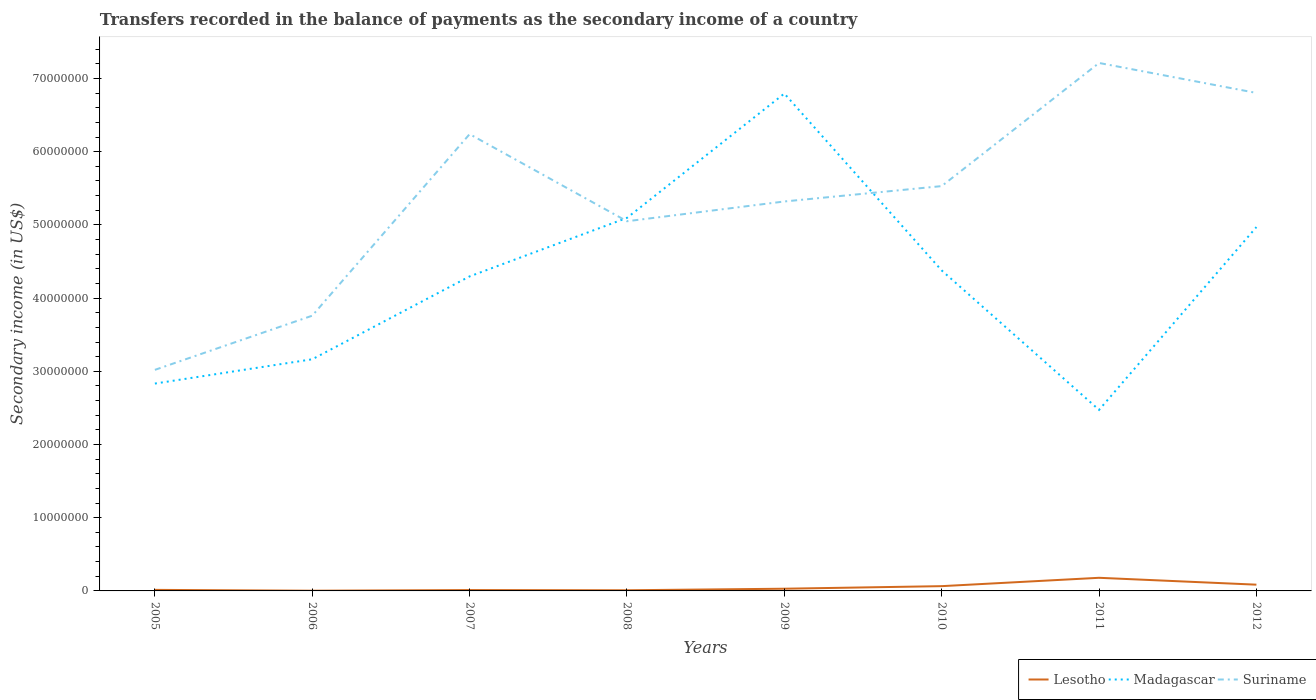Does the line corresponding to Lesotho intersect with the line corresponding to Madagascar?
Offer a terse response. No. Is the number of lines equal to the number of legend labels?
Ensure brevity in your answer.  Yes. Across all years, what is the maximum secondary income of in Madagascar?
Offer a terse response. 2.47e+07. In which year was the secondary income of in Lesotho maximum?
Keep it short and to the point. 2006. What is the total secondary income of in Suriname in the graph?
Provide a succinct answer. -1.77e+07. What is the difference between the highest and the second highest secondary income of in Madagascar?
Offer a terse response. 4.32e+07. What is the difference between the highest and the lowest secondary income of in Madagascar?
Your answer should be very brief. 5. Is the secondary income of in Madagascar strictly greater than the secondary income of in Lesotho over the years?
Ensure brevity in your answer.  No. How many lines are there?
Your response must be concise. 3. Are the values on the major ticks of Y-axis written in scientific E-notation?
Your answer should be very brief. No. Does the graph contain any zero values?
Keep it short and to the point. No. Where does the legend appear in the graph?
Provide a succinct answer. Bottom right. How many legend labels are there?
Provide a short and direct response. 3. How are the legend labels stacked?
Offer a very short reply. Horizontal. What is the title of the graph?
Offer a very short reply. Transfers recorded in the balance of payments as the secondary income of a country. Does "United Kingdom" appear as one of the legend labels in the graph?
Your response must be concise. No. What is the label or title of the Y-axis?
Offer a very short reply. Secondary income (in US$). What is the Secondary income (in US$) in Lesotho in 2005?
Your answer should be compact. 1.43e+05. What is the Secondary income (in US$) of Madagascar in 2005?
Ensure brevity in your answer.  2.83e+07. What is the Secondary income (in US$) in Suriname in 2005?
Keep it short and to the point. 3.02e+07. What is the Secondary income (in US$) in Lesotho in 2006?
Provide a succinct answer. 2.97e+04. What is the Secondary income (in US$) of Madagascar in 2006?
Ensure brevity in your answer.  3.16e+07. What is the Secondary income (in US$) of Suriname in 2006?
Make the answer very short. 3.76e+07. What is the Secondary income (in US$) of Lesotho in 2007?
Make the answer very short. 1.18e+05. What is the Secondary income (in US$) in Madagascar in 2007?
Provide a short and direct response. 4.30e+07. What is the Secondary income (in US$) in Suriname in 2007?
Provide a short and direct response. 6.24e+07. What is the Secondary income (in US$) in Lesotho in 2008?
Provide a short and direct response. 9.02e+04. What is the Secondary income (in US$) of Madagascar in 2008?
Your answer should be compact. 5.10e+07. What is the Secondary income (in US$) of Suriname in 2008?
Make the answer very short. 5.05e+07. What is the Secondary income (in US$) of Lesotho in 2009?
Give a very brief answer. 3.02e+05. What is the Secondary income (in US$) in Madagascar in 2009?
Offer a very short reply. 6.79e+07. What is the Secondary income (in US$) of Suriname in 2009?
Your answer should be compact. 5.32e+07. What is the Secondary income (in US$) of Lesotho in 2010?
Your response must be concise. 6.52e+05. What is the Secondary income (in US$) in Madagascar in 2010?
Offer a terse response. 4.38e+07. What is the Secondary income (in US$) in Suriname in 2010?
Make the answer very short. 5.53e+07. What is the Secondary income (in US$) in Lesotho in 2011?
Keep it short and to the point. 1.79e+06. What is the Secondary income (in US$) of Madagascar in 2011?
Provide a succinct answer. 2.47e+07. What is the Secondary income (in US$) of Suriname in 2011?
Your answer should be compact. 7.21e+07. What is the Secondary income (in US$) in Lesotho in 2012?
Ensure brevity in your answer.  8.54e+05. What is the Secondary income (in US$) of Madagascar in 2012?
Give a very brief answer. 4.97e+07. What is the Secondary income (in US$) in Suriname in 2012?
Your answer should be compact. 6.80e+07. Across all years, what is the maximum Secondary income (in US$) in Lesotho?
Your response must be concise. 1.79e+06. Across all years, what is the maximum Secondary income (in US$) of Madagascar?
Ensure brevity in your answer.  6.79e+07. Across all years, what is the maximum Secondary income (in US$) of Suriname?
Keep it short and to the point. 7.21e+07. Across all years, what is the minimum Secondary income (in US$) of Lesotho?
Keep it short and to the point. 2.97e+04. Across all years, what is the minimum Secondary income (in US$) in Madagascar?
Keep it short and to the point. 2.47e+07. Across all years, what is the minimum Secondary income (in US$) in Suriname?
Offer a very short reply. 3.02e+07. What is the total Secondary income (in US$) of Lesotho in the graph?
Ensure brevity in your answer.  3.98e+06. What is the total Secondary income (in US$) of Madagascar in the graph?
Your answer should be very brief. 3.40e+08. What is the total Secondary income (in US$) of Suriname in the graph?
Keep it short and to the point. 4.29e+08. What is the difference between the Secondary income (in US$) of Lesotho in 2005 and that in 2006?
Give a very brief answer. 1.13e+05. What is the difference between the Secondary income (in US$) in Madagascar in 2005 and that in 2006?
Ensure brevity in your answer.  -3.32e+06. What is the difference between the Secondary income (in US$) of Suriname in 2005 and that in 2006?
Make the answer very short. -7.40e+06. What is the difference between the Secondary income (in US$) of Lesotho in 2005 and that in 2007?
Make the answer very short. 2.51e+04. What is the difference between the Secondary income (in US$) of Madagascar in 2005 and that in 2007?
Offer a terse response. -1.46e+07. What is the difference between the Secondary income (in US$) in Suriname in 2005 and that in 2007?
Keep it short and to the point. -3.22e+07. What is the difference between the Secondary income (in US$) of Lesotho in 2005 and that in 2008?
Give a very brief answer. 5.25e+04. What is the difference between the Secondary income (in US$) in Madagascar in 2005 and that in 2008?
Offer a terse response. -2.26e+07. What is the difference between the Secondary income (in US$) of Suriname in 2005 and that in 2008?
Provide a succinct answer. -2.03e+07. What is the difference between the Secondary income (in US$) of Lesotho in 2005 and that in 2009?
Give a very brief answer. -1.59e+05. What is the difference between the Secondary income (in US$) in Madagascar in 2005 and that in 2009?
Provide a succinct answer. -3.96e+07. What is the difference between the Secondary income (in US$) of Suriname in 2005 and that in 2009?
Keep it short and to the point. -2.30e+07. What is the difference between the Secondary income (in US$) of Lesotho in 2005 and that in 2010?
Offer a very short reply. -5.09e+05. What is the difference between the Secondary income (in US$) of Madagascar in 2005 and that in 2010?
Your response must be concise. -1.55e+07. What is the difference between the Secondary income (in US$) in Suriname in 2005 and that in 2010?
Keep it short and to the point. -2.51e+07. What is the difference between the Secondary income (in US$) in Lesotho in 2005 and that in 2011?
Your answer should be very brief. -1.65e+06. What is the difference between the Secondary income (in US$) in Madagascar in 2005 and that in 2011?
Give a very brief answer. 3.60e+06. What is the difference between the Secondary income (in US$) in Suriname in 2005 and that in 2011?
Your answer should be compact. -4.19e+07. What is the difference between the Secondary income (in US$) of Lesotho in 2005 and that in 2012?
Keep it short and to the point. -7.11e+05. What is the difference between the Secondary income (in US$) of Madagascar in 2005 and that in 2012?
Provide a short and direct response. -2.14e+07. What is the difference between the Secondary income (in US$) of Suriname in 2005 and that in 2012?
Your answer should be compact. -3.78e+07. What is the difference between the Secondary income (in US$) of Lesotho in 2006 and that in 2007?
Provide a short and direct response. -8.79e+04. What is the difference between the Secondary income (in US$) in Madagascar in 2006 and that in 2007?
Keep it short and to the point. -1.13e+07. What is the difference between the Secondary income (in US$) in Suriname in 2006 and that in 2007?
Your answer should be compact. -2.48e+07. What is the difference between the Secondary income (in US$) in Lesotho in 2006 and that in 2008?
Provide a short and direct response. -6.05e+04. What is the difference between the Secondary income (in US$) of Madagascar in 2006 and that in 2008?
Keep it short and to the point. -1.93e+07. What is the difference between the Secondary income (in US$) in Suriname in 2006 and that in 2008?
Make the answer very short. -1.29e+07. What is the difference between the Secondary income (in US$) of Lesotho in 2006 and that in 2009?
Make the answer very short. -2.72e+05. What is the difference between the Secondary income (in US$) in Madagascar in 2006 and that in 2009?
Make the answer very short. -3.63e+07. What is the difference between the Secondary income (in US$) of Suriname in 2006 and that in 2009?
Give a very brief answer. -1.56e+07. What is the difference between the Secondary income (in US$) of Lesotho in 2006 and that in 2010?
Provide a short and direct response. -6.22e+05. What is the difference between the Secondary income (in US$) in Madagascar in 2006 and that in 2010?
Keep it short and to the point. -1.21e+07. What is the difference between the Secondary income (in US$) in Suriname in 2006 and that in 2010?
Make the answer very short. -1.77e+07. What is the difference between the Secondary income (in US$) in Lesotho in 2006 and that in 2011?
Provide a succinct answer. -1.76e+06. What is the difference between the Secondary income (in US$) in Madagascar in 2006 and that in 2011?
Make the answer very short. 6.91e+06. What is the difference between the Secondary income (in US$) in Suriname in 2006 and that in 2011?
Give a very brief answer. -3.45e+07. What is the difference between the Secondary income (in US$) in Lesotho in 2006 and that in 2012?
Ensure brevity in your answer.  -8.24e+05. What is the difference between the Secondary income (in US$) in Madagascar in 2006 and that in 2012?
Make the answer very short. -1.81e+07. What is the difference between the Secondary income (in US$) in Suriname in 2006 and that in 2012?
Your answer should be compact. -3.04e+07. What is the difference between the Secondary income (in US$) in Lesotho in 2007 and that in 2008?
Your answer should be compact. 2.74e+04. What is the difference between the Secondary income (in US$) of Madagascar in 2007 and that in 2008?
Offer a terse response. -7.99e+06. What is the difference between the Secondary income (in US$) in Suriname in 2007 and that in 2008?
Give a very brief answer. 1.19e+07. What is the difference between the Secondary income (in US$) of Lesotho in 2007 and that in 2009?
Make the answer very short. -1.84e+05. What is the difference between the Secondary income (in US$) of Madagascar in 2007 and that in 2009?
Make the answer very short. -2.50e+07. What is the difference between the Secondary income (in US$) in Suriname in 2007 and that in 2009?
Offer a terse response. 9.20e+06. What is the difference between the Secondary income (in US$) of Lesotho in 2007 and that in 2010?
Make the answer very short. -5.34e+05. What is the difference between the Secondary income (in US$) of Madagascar in 2007 and that in 2010?
Your answer should be very brief. -8.12e+05. What is the difference between the Secondary income (in US$) of Suriname in 2007 and that in 2010?
Offer a terse response. 7.10e+06. What is the difference between the Secondary income (in US$) in Lesotho in 2007 and that in 2011?
Keep it short and to the point. -1.68e+06. What is the difference between the Secondary income (in US$) in Madagascar in 2007 and that in 2011?
Your response must be concise. 1.82e+07. What is the difference between the Secondary income (in US$) of Suriname in 2007 and that in 2011?
Offer a very short reply. -9.72e+06. What is the difference between the Secondary income (in US$) in Lesotho in 2007 and that in 2012?
Keep it short and to the point. -7.36e+05. What is the difference between the Secondary income (in US$) of Madagascar in 2007 and that in 2012?
Make the answer very short. -6.74e+06. What is the difference between the Secondary income (in US$) in Suriname in 2007 and that in 2012?
Provide a succinct answer. -5.63e+06. What is the difference between the Secondary income (in US$) in Lesotho in 2008 and that in 2009?
Keep it short and to the point. -2.11e+05. What is the difference between the Secondary income (in US$) of Madagascar in 2008 and that in 2009?
Your answer should be compact. -1.70e+07. What is the difference between the Secondary income (in US$) of Suriname in 2008 and that in 2009?
Provide a succinct answer. -2.70e+06. What is the difference between the Secondary income (in US$) of Lesotho in 2008 and that in 2010?
Your answer should be very brief. -5.62e+05. What is the difference between the Secondary income (in US$) of Madagascar in 2008 and that in 2010?
Give a very brief answer. 7.18e+06. What is the difference between the Secondary income (in US$) of Suriname in 2008 and that in 2010?
Provide a short and direct response. -4.80e+06. What is the difference between the Secondary income (in US$) of Lesotho in 2008 and that in 2011?
Ensure brevity in your answer.  -1.70e+06. What is the difference between the Secondary income (in US$) of Madagascar in 2008 and that in 2011?
Offer a terse response. 2.62e+07. What is the difference between the Secondary income (in US$) of Suriname in 2008 and that in 2011?
Provide a succinct answer. -2.16e+07. What is the difference between the Secondary income (in US$) of Lesotho in 2008 and that in 2012?
Make the answer very short. -7.64e+05. What is the difference between the Secondary income (in US$) in Madagascar in 2008 and that in 2012?
Offer a terse response. 1.25e+06. What is the difference between the Secondary income (in US$) in Suriname in 2008 and that in 2012?
Give a very brief answer. -1.75e+07. What is the difference between the Secondary income (in US$) in Lesotho in 2009 and that in 2010?
Your response must be concise. -3.50e+05. What is the difference between the Secondary income (in US$) in Madagascar in 2009 and that in 2010?
Your answer should be very brief. 2.42e+07. What is the difference between the Secondary income (in US$) in Suriname in 2009 and that in 2010?
Keep it short and to the point. -2.10e+06. What is the difference between the Secondary income (in US$) in Lesotho in 2009 and that in 2011?
Make the answer very short. -1.49e+06. What is the difference between the Secondary income (in US$) in Madagascar in 2009 and that in 2011?
Offer a terse response. 4.32e+07. What is the difference between the Secondary income (in US$) of Suriname in 2009 and that in 2011?
Provide a short and direct response. -1.89e+07. What is the difference between the Secondary income (in US$) in Lesotho in 2009 and that in 2012?
Provide a short and direct response. -5.52e+05. What is the difference between the Secondary income (in US$) of Madagascar in 2009 and that in 2012?
Offer a terse response. 1.82e+07. What is the difference between the Secondary income (in US$) in Suriname in 2009 and that in 2012?
Keep it short and to the point. -1.48e+07. What is the difference between the Secondary income (in US$) in Lesotho in 2010 and that in 2011?
Offer a very short reply. -1.14e+06. What is the difference between the Secondary income (in US$) in Madagascar in 2010 and that in 2011?
Your answer should be compact. 1.90e+07. What is the difference between the Secondary income (in US$) in Suriname in 2010 and that in 2011?
Offer a very short reply. -1.68e+07. What is the difference between the Secondary income (in US$) of Lesotho in 2010 and that in 2012?
Provide a succinct answer. -2.02e+05. What is the difference between the Secondary income (in US$) in Madagascar in 2010 and that in 2012?
Offer a very short reply. -5.93e+06. What is the difference between the Secondary income (in US$) of Suriname in 2010 and that in 2012?
Provide a succinct answer. -1.27e+07. What is the difference between the Secondary income (in US$) of Lesotho in 2011 and that in 2012?
Offer a very short reply. 9.39e+05. What is the difference between the Secondary income (in US$) in Madagascar in 2011 and that in 2012?
Offer a terse response. -2.50e+07. What is the difference between the Secondary income (in US$) in Suriname in 2011 and that in 2012?
Your answer should be very brief. 4.09e+06. What is the difference between the Secondary income (in US$) in Lesotho in 2005 and the Secondary income (in US$) in Madagascar in 2006?
Your answer should be very brief. -3.15e+07. What is the difference between the Secondary income (in US$) in Lesotho in 2005 and the Secondary income (in US$) in Suriname in 2006?
Ensure brevity in your answer.  -3.75e+07. What is the difference between the Secondary income (in US$) of Madagascar in 2005 and the Secondary income (in US$) of Suriname in 2006?
Make the answer very short. -9.27e+06. What is the difference between the Secondary income (in US$) in Lesotho in 2005 and the Secondary income (in US$) in Madagascar in 2007?
Offer a terse response. -4.28e+07. What is the difference between the Secondary income (in US$) of Lesotho in 2005 and the Secondary income (in US$) of Suriname in 2007?
Keep it short and to the point. -6.23e+07. What is the difference between the Secondary income (in US$) in Madagascar in 2005 and the Secondary income (in US$) in Suriname in 2007?
Give a very brief answer. -3.41e+07. What is the difference between the Secondary income (in US$) in Lesotho in 2005 and the Secondary income (in US$) in Madagascar in 2008?
Ensure brevity in your answer.  -5.08e+07. What is the difference between the Secondary income (in US$) in Lesotho in 2005 and the Secondary income (in US$) in Suriname in 2008?
Provide a short and direct response. -5.04e+07. What is the difference between the Secondary income (in US$) of Madagascar in 2005 and the Secondary income (in US$) of Suriname in 2008?
Make the answer very short. -2.22e+07. What is the difference between the Secondary income (in US$) of Lesotho in 2005 and the Secondary income (in US$) of Madagascar in 2009?
Your answer should be very brief. -6.78e+07. What is the difference between the Secondary income (in US$) of Lesotho in 2005 and the Secondary income (in US$) of Suriname in 2009?
Keep it short and to the point. -5.31e+07. What is the difference between the Secondary income (in US$) in Madagascar in 2005 and the Secondary income (in US$) in Suriname in 2009?
Your response must be concise. -2.49e+07. What is the difference between the Secondary income (in US$) of Lesotho in 2005 and the Secondary income (in US$) of Madagascar in 2010?
Keep it short and to the point. -4.36e+07. What is the difference between the Secondary income (in US$) of Lesotho in 2005 and the Secondary income (in US$) of Suriname in 2010?
Offer a terse response. -5.52e+07. What is the difference between the Secondary income (in US$) in Madagascar in 2005 and the Secondary income (in US$) in Suriname in 2010?
Ensure brevity in your answer.  -2.70e+07. What is the difference between the Secondary income (in US$) of Lesotho in 2005 and the Secondary income (in US$) of Madagascar in 2011?
Keep it short and to the point. -2.46e+07. What is the difference between the Secondary income (in US$) in Lesotho in 2005 and the Secondary income (in US$) in Suriname in 2011?
Provide a short and direct response. -7.20e+07. What is the difference between the Secondary income (in US$) in Madagascar in 2005 and the Secondary income (in US$) in Suriname in 2011?
Provide a short and direct response. -4.38e+07. What is the difference between the Secondary income (in US$) of Lesotho in 2005 and the Secondary income (in US$) of Madagascar in 2012?
Provide a succinct answer. -4.96e+07. What is the difference between the Secondary income (in US$) of Lesotho in 2005 and the Secondary income (in US$) of Suriname in 2012?
Offer a very short reply. -6.79e+07. What is the difference between the Secondary income (in US$) of Madagascar in 2005 and the Secondary income (in US$) of Suriname in 2012?
Your answer should be compact. -3.97e+07. What is the difference between the Secondary income (in US$) of Lesotho in 2006 and the Secondary income (in US$) of Madagascar in 2007?
Your response must be concise. -4.29e+07. What is the difference between the Secondary income (in US$) in Lesotho in 2006 and the Secondary income (in US$) in Suriname in 2007?
Offer a terse response. -6.24e+07. What is the difference between the Secondary income (in US$) in Madagascar in 2006 and the Secondary income (in US$) in Suriname in 2007?
Your answer should be compact. -3.08e+07. What is the difference between the Secondary income (in US$) of Lesotho in 2006 and the Secondary income (in US$) of Madagascar in 2008?
Your response must be concise. -5.09e+07. What is the difference between the Secondary income (in US$) in Lesotho in 2006 and the Secondary income (in US$) in Suriname in 2008?
Provide a succinct answer. -5.05e+07. What is the difference between the Secondary income (in US$) of Madagascar in 2006 and the Secondary income (in US$) of Suriname in 2008?
Provide a short and direct response. -1.89e+07. What is the difference between the Secondary income (in US$) of Lesotho in 2006 and the Secondary income (in US$) of Madagascar in 2009?
Your response must be concise. -6.79e+07. What is the difference between the Secondary income (in US$) of Lesotho in 2006 and the Secondary income (in US$) of Suriname in 2009?
Provide a short and direct response. -5.32e+07. What is the difference between the Secondary income (in US$) of Madagascar in 2006 and the Secondary income (in US$) of Suriname in 2009?
Keep it short and to the point. -2.16e+07. What is the difference between the Secondary income (in US$) of Lesotho in 2006 and the Secondary income (in US$) of Madagascar in 2010?
Your response must be concise. -4.37e+07. What is the difference between the Secondary income (in US$) of Lesotho in 2006 and the Secondary income (in US$) of Suriname in 2010?
Give a very brief answer. -5.53e+07. What is the difference between the Secondary income (in US$) of Madagascar in 2006 and the Secondary income (in US$) of Suriname in 2010?
Provide a short and direct response. -2.37e+07. What is the difference between the Secondary income (in US$) in Lesotho in 2006 and the Secondary income (in US$) in Madagascar in 2011?
Give a very brief answer. -2.47e+07. What is the difference between the Secondary income (in US$) of Lesotho in 2006 and the Secondary income (in US$) of Suriname in 2011?
Ensure brevity in your answer.  -7.21e+07. What is the difference between the Secondary income (in US$) in Madagascar in 2006 and the Secondary income (in US$) in Suriname in 2011?
Your answer should be compact. -4.05e+07. What is the difference between the Secondary income (in US$) in Lesotho in 2006 and the Secondary income (in US$) in Madagascar in 2012?
Ensure brevity in your answer.  -4.97e+07. What is the difference between the Secondary income (in US$) of Lesotho in 2006 and the Secondary income (in US$) of Suriname in 2012?
Make the answer very short. -6.80e+07. What is the difference between the Secondary income (in US$) in Madagascar in 2006 and the Secondary income (in US$) in Suriname in 2012?
Make the answer very short. -3.64e+07. What is the difference between the Secondary income (in US$) in Lesotho in 2007 and the Secondary income (in US$) in Madagascar in 2008?
Keep it short and to the point. -5.08e+07. What is the difference between the Secondary income (in US$) in Lesotho in 2007 and the Secondary income (in US$) in Suriname in 2008?
Give a very brief answer. -5.04e+07. What is the difference between the Secondary income (in US$) in Madagascar in 2007 and the Secondary income (in US$) in Suriname in 2008?
Provide a succinct answer. -7.53e+06. What is the difference between the Secondary income (in US$) of Lesotho in 2007 and the Secondary income (in US$) of Madagascar in 2009?
Your response must be concise. -6.78e+07. What is the difference between the Secondary income (in US$) of Lesotho in 2007 and the Secondary income (in US$) of Suriname in 2009?
Offer a very short reply. -5.31e+07. What is the difference between the Secondary income (in US$) in Madagascar in 2007 and the Secondary income (in US$) in Suriname in 2009?
Keep it short and to the point. -1.02e+07. What is the difference between the Secondary income (in US$) in Lesotho in 2007 and the Secondary income (in US$) in Madagascar in 2010?
Your answer should be very brief. -4.37e+07. What is the difference between the Secondary income (in US$) in Lesotho in 2007 and the Secondary income (in US$) in Suriname in 2010?
Ensure brevity in your answer.  -5.52e+07. What is the difference between the Secondary income (in US$) in Madagascar in 2007 and the Secondary income (in US$) in Suriname in 2010?
Your answer should be very brief. -1.23e+07. What is the difference between the Secondary income (in US$) in Lesotho in 2007 and the Secondary income (in US$) in Madagascar in 2011?
Give a very brief answer. -2.46e+07. What is the difference between the Secondary income (in US$) of Lesotho in 2007 and the Secondary income (in US$) of Suriname in 2011?
Provide a succinct answer. -7.20e+07. What is the difference between the Secondary income (in US$) in Madagascar in 2007 and the Secondary income (in US$) in Suriname in 2011?
Provide a short and direct response. -2.92e+07. What is the difference between the Secondary income (in US$) of Lesotho in 2007 and the Secondary income (in US$) of Madagascar in 2012?
Ensure brevity in your answer.  -4.96e+07. What is the difference between the Secondary income (in US$) of Lesotho in 2007 and the Secondary income (in US$) of Suriname in 2012?
Provide a short and direct response. -6.79e+07. What is the difference between the Secondary income (in US$) of Madagascar in 2007 and the Secondary income (in US$) of Suriname in 2012?
Keep it short and to the point. -2.51e+07. What is the difference between the Secondary income (in US$) of Lesotho in 2008 and the Secondary income (in US$) of Madagascar in 2009?
Provide a succinct answer. -6.79e+07. What is the difference between the Secondary income (in US$) in Lesotho in 2008 and the Secondary income (in US$) in Suriname in 2009?
Provide a short and direct response. -5.31e+07. What is the difference between the Secondary income (in US$) of Madagascar in 2008 and the Secondary income (in US$) of Suriname in 2009?
Offer a terse response. -2.24e+06. What is the difference between the Secondary income (in US$) of Lesotho in 2008 and the Secondary income (in US$) of Madagascar in 2010?
Provide a succinct answer. -4.37e+07. What is the difference between the Secondary income (in US$) of Lesotho in 2008 and the Secondary income (in US$) of Suriname in 2010?
Keep it short and to the point. -5.52e+07. What is the difference between the Secondary income (in US$) in Madagascar in 2008 and the Secondary income (in US$) in Suriname in 2010?
Keep it short and to the point. -4.34e+06. What is the difference between the Secondary income (in US$) of Lesotho in 2008 and the Secondary income (in US$) of Madagascar in 2011?
Give a very brief answer. -2.46e+07. What is the difference between the Secondary income (in US$) of Lesotho in 2008 and the Secondary income (in US$) of Suriname in 2011?
Your answer should be very brief. -7.20e+07. What is the difference between the Secondary income (in US$) in Madagascar in 2008 and the Secondary income (in US$) in Suriname in 2011?
Keep it short and to the point. -2.12e+07. What is the difference between the Secondary income (in US$) in Lesotho in 2008 and the Secondary income (in US$) in Madagascar in 2012?
Your answer should be very brief. -4.96e+07. What is the difference between the Secondary income (in US$) of Lesotho in 2008 and the Secondary income (in US$) of Suriname in 2012?
Provide a short and direct response. -6.79e+07. What is the difference between the Secondary income (in US$) of Madagascar in 2008 and the Secondary income (in US$) of Suriname in 2012?
Provide a short and direct response. -1.71e+07. What is the difference between the Secondary income (in US$) of Lesotho in 2009 and the Secondary income (in US$) of Madagascar in 2010?
Offer a very short reply. -4.35e+07. What is the difference between the Secondary income (in US$) of Lesotho in 2009 and the Secondary income (in US$) of Suriname in 2010?
Your answer should be compact. -5.50e+07. What is the difference between the Secondary income (in US$) of Madagascar in 2009 and the Secondary income (in US$) of Suriname in 2010?
Give a very brief answer. 1.26e+07. What is the difference between the Secondary income (in US$) in Lesotho in 2009 and the Secondary income (in US$) in Madagascar in 2011?
Your answer should be very brief. -2.44e+07. What is the difference between the Secondary income (in US$) of Lesotho in 2009 and the Secondary income (in US$) of Suriname in 2011?
Provide a succinct answer. -7.18e+07. What is the difference between the Secondary income (in US$) of Madagascar in 2009 and the Secondary income (in US$) of Suriname in 2011?
Make the answer very short. -4.18e+06. What is the difference between the Secondary income (in US$) in Lesotho in 2009 and the Secondary income (in US$) in Madagascar in 2012?
Your answer should be compact. -4.94e+07. What is the difference between the Secondary income (in US$) of Lesotho in 2009 and the Secondary income (in US$) of Suriname in 2012?
Your response must be concise. -6.77e+07. What is the difference between the Secondary income (in US$) in Madagascar in 2009 and the Secondary income (in US$) in Suriname in 2012?
Provide a succinct answer. -8.49e+04. What is the difference between the Secondary income (in US$) of Lesotho in 2010 and the Secondary income (in US$) of Madagascar in 2011?
Provide a succinct answer. -2.41e+07. What is the difference between the Secondary income (in US$) in Lesotho in 2010 and the Secondary income (in US$) in Suriname in 2011?
Your answer should be very brief. -7.15e+07. What is the difference between the Secondary income (in US$) in Madagascar in 2010 and the Secondary income (in US$) in Suriname in 2011?
Your answer should be compact. -2.83e+07. What is the difference between the Secondary income (in US$) in Lesotho in 2010 and the Secondary income (in US$) in Madagascar in 2012?
Keep it short and to the point. -4.91e+07. What is the difference between the Secondary income (in US$) of Lesotho in 2010 and the Secondary income (in US$) of Suriname in 2012?
Keep it short and to the point. -6.74e+07. What is the difference between the Secondary income (in US$) in Madagascar in 2010 and the Secondary income (in US$) in Suriname in 2012?
Offer a very short reply. -2.42e+07. What is the difference between the Secondary income (in US$) of Lesotho in 2011 and the Secondary income (in US$) of Madagascar in 2012?
Offer a very short reply. -4.79e+07. What is the difference between the Secondary income (in US$) in Lesotho in 2011 and the Secondary income (in US$) in Suriname in 2012?
Your response must be concise. -6.62e+07. What is the difference between the Secondary income (in US$) in Madagascar in 2011 and the Secondary income (in US$) in Suriname in 2012?
Provide a short and direct response. -4.33e+07. What is the average Secondary income (in US$) of Lesotho per year?
Keep it short and to the point. 4.98e+05. What is the average Secondary income (in US$) of Madagascar per year?
Your response must be concise. 4.25e+07. What is the average Secondary income (in US$) of Suriname per year?
Ensure brevity in your answer.  5.37e+07. In the year 2005, what is the difference between the Secondary income (in US$) in Lesotho and Secondary income (in US$) in Madagascar?
Your response must be concise. -2.82e+07. In the year 2005, what is the difference between the Secondary income (in US$) in Lesotho and Secondary income (in US$) in Suriname?
Give a very brief answer. -3.01e+07. In the year 2005, what is the difference between the Secondary income (in US$) of Madagascar and Secondary income (in US$) of Suriname?
Keep it short and to the point. -1.87e+06. In the year 2006, what is the difference between the Secondary income (in US$) of Lesotho and Secondary income (in US$) of Madagascar?
Give a very brief answer. -3.16e+07. In the year 2006, what is the difference between the Secondary income (in US$) in Lesotho and Secondary income (in US$) in Suriname?
Keep it short and to the point. -3.76e+07. In the year 2006, what is the difference between the Secondary income (in US$) of Madagascar and Secondary income (in US$) of Suriname?
Your answer should be compact. -5.96e+06. In the year 2007, what is the difference between the Secondary income (in US$) in Lesotho and Secondary income (in US$) in Madagascar?
Keep it short and to the point. -4.28e+07. In the year 2007, what is the difference between the Secondary income (in US$) of Lesotho and Secondary income (in US$) of Suriname?
Your answer should be very brief. -6.23e+07. In the year 2007, what is the difference between the Secondary income (in US$) in Madagascar and Secondary income (in US$) in Suriname?
Offer a terse response. -1.94e+07. In the year 2008, what is the difference between the Secondary income (in US$) of Lesotho and Secondary income (in US$) of Madagascar?
Your response must be concise. -5.09e+07. In the year 2008, what is the difference between the Secondary income (in US$) of Lesotho and Secondary income (in US$) of Suriname?
Offer a terse response. -5.04e+07. In the year 2008, what is the difference between the Secondary income (in US$) of Madagascar and Secondary income (in US$) of Suriname?
Ensure brevity in your answer.  4.59e+05. In the year 2009, what is the difference between the Secondary income (in US$) of Lesotho and Secondary income (in US$) of Madagascar?
Make the answer very short. -6.76e+07. In the year 2009, what is the difference between the Secondary income (in US$) in Lesotho and Secondary income (in US$) in Suriname?
Your answer should be compact. -5.29e+07. In the year 2009, what is the difference between the Secondary income (in US$) of Madagascar and Secondary income (in US$) of Suriname?
Keep it short and to the point. 1.47e+07. In the year 2010, what is the difference between the Secondary income (in US$) in Lesotho and Secondary income (in US$) in Madagascar?
Keep it short and to the point. -4.31e+07. In the year 2010, what is the difference between the Secondary income (in US$) of Lesotho and Secondary income (in US$) of Suriname?
Your answer should be compact. -5.46e+07. In the year 2010, what is the difference between the Secondary income (in US$) of Madagascar and Secondary income (in US$) of Suriname?
Offer a very short reply. -1.15e+07. In the year 2011, what is the difference between the Secondary income (in US$) in Lesotho and Secondary income (in US$) in Madagascar?
Provide a short and direct response. -2.29e+07. In the year 2011, what is the difference between the Secondary income (in US$) of Lesotho and Secondary income (in US$) of Suriname?
Your answer should be compact. -7.03e+07. In the year 2011, what is the difference between the Secondary income (in US$) in Madagascar and Secondary income (in US$) in Suriname?
Offer a terse response. -4.74e+07. In the year 2012, what is the difference between the Secondary income (in US$) of Lesotho and Secondary income (in US$) of Madagascar?
Keep it short and to the point. -4.89e+07. In the year 2012, what is the difference between the Secondary income (in US$) in Lesotho and Secondary income (in US$) in Suriname?
Your answer should be very brief. -6.72e+07. In the year 2012, what is the difference between the Secondary income (in US$) of Madagascar and Secondary income (in US$) of Suriname?
Give a very brief answer. -1.83e+07. What is the ratio of the Secondary income (in US$) of Lesotho in 2005 to that in 2006?
Keep it short and to the point. 4.81. What is the ratio of the Secondary income (in US$) in Madagascar in 2005 to that in 2006?
Your answer should be very brief. 0.9. What is the ratio of the Secondary income (in US$) of Suriname in 2005 to that in 2006?
Make the answer very short. 0.8. What is the ratio of the Secondary income (in US$) in Lesotho in 2005 to that in 2007?
Give a very brief answer. 1.21. What is the ratio of the Secondary income (in US$) in Madagascar in 2005 to that in 2007?
Make the answer very short. 0.66. What is the ratio of the Secondary income (in US$) of Suriname in 2005 to that in 2007?
Your answer should be compact. 0.48. What is the ratio of the Secondary income (in US$) of Lesotho in 2005 to that in 2008?
Offer a very short reply. 1.58. What is the ratio of the Secondary income (in US$) in Madagascar in 2005 to that in 2008?
Make the answer very short. 0.56. What is the ratio of the Secondary income (in US$) in Suriname in 2005 to that in 2008?
Your answer should be very brief. 0.6. What is the ratio of the Secondary income (in US$) in Lesotho in 2005 to that in 2009?
Your answer should be compact. 0.47. What is the ratio of the Secondary income (in US$) in Madagascar in 2005 to that in 2009?
Keep it short and to the point. 0.42. What is the ratio of the Secondary income (in US$) of Suriname in 2005 to that in 2009?
Ensure brevity in your answer.  0.57. What is the ratio of the Secondary income (in US$) of Lesotho in 2005 to that in 2010?
Your response must be concise. 0.22. What is the ratio of the Secondary income (in US$) in Madagascar in 2005 to that in 2010?
Keep it short and to the point. 0.65. What is the ratio of the Secondary income (in US$) of Suriname in 2005 to that in 2010?
Keep it short and to the point. 0.55. What is the ratio of the Secondary income (in US$) of Lesotho in 2005 to that in 2011?
Your response must be concise. 0.08. What is the ratio of the Secondary income (in US$) of Madagascar in 2005 to that in 2011?
Offer a very short reply. 1.15. What is the ratio of the Secondary income (in US$) of Suriname in 2005 to that in 2011?
Provide a short and direct response. 0.42. What is the ratio of the Secondary income (in US$) of Lesotho in 2005 to that in 2012?
Keep it short and to the point. 0.17. What is the ratio of the Secondary income (in US$) of Madagascar in 2005 to that in 2012?
Keep it short and to the point. 0.57. What is the ratio of the Secondary income (in US$) of Suriname in 2005 to that in 2012?
Your answer should be compact. 0.44. What is the ratio of the Secondary income (in US$) of Lesotho in 2006 to that in 2007?
Provide a succinct answer. 0.25. What is the ratio of the Secondary income (in US$) in Madagascar in 2006 to that in 2007?
Your response must be concise. 0.74. What is the ratio of the Secondary income (in US$) of Suriname in 2006 to that in 2007?
Your response must be concise. 0.6. What is the ratio of the Secondary income (in US$) in Lesotho in 2006 to that in 2008?
Keep it short and to the point. 0.33. What is the ratio of the Secondary income (in US$) in Madagascar in 2006 to that in 2008?
Keep it short and to the point. 0.62. What is the ratio of the Secondary income (in US$) of Suriname in 2006 to that in 2008?
Offer a very short reply. 0.74. What is the ratio of the Secondary income (in US$) of Lesotho in 2006 to that in 2009?
Offer a terse response. 0.1. What is the ratio of the Secondary income (in US$) in Madagascar in 2006 to that in 2009?
Your response must be concise. 0.47. What is the ratio of the Secondary income (in US$) of Suriname in 2006 to that in 2009?
Your answer should be compact. 0.71. What is the ratio of the Secondary income (in US$) of Lesotho in 2006 to that in 2010?
Make the answer very short. 0.05. What is the ratio of the Secondary income (in US$) of Madagascar in 2006 to that in 2010?
Keep it short and to the point. 0.72. What is the ratio of the Secondary income (in US$) in Suriname in 2006 to that in 2010?
Make the answer very short. 0.68. What is the ratio of the Secondary income (in US$) in Lesotho in 2006 to that in 2011?
Your answer should be very brief. 0.02. What is the ratio of the Secondary income (in US$) of Madagascar in 2006 to that in 2011?
Offer a very short reply. 1.28. What is the ratio of the Secondary income (in US$) in Suriname in 2006 to that in 2011?
Your answer should be compact. 0.52. What is the ratio of the Secondary income (in US$) in Lesotho in 2006 to that in 2012?
Provide a short and direct response. 0.03. What is the ratio of the Secondary income (in US$) in Madagascar in 2006 to that in 2012?
Ensure brevity in your answer.  0.64. What is the ratio of the Secondary income (in US$) in Suriname in 2006 to that in 2012?
Ensure brevity in your answer.  0.55. What is the ratio of the Secondary income (in US$) of Lesotho in 2007 to that in 2008?
Make the answer very short. 1.3. What is the ratio of the Secondary income (in US$) of Madagascar in 2007 to that in 2008?
Your response must be concise. 0.84. What is the ratio of the Secondary income (in US$) of Suriname in 2007 to that in 2008?
Give a very brief answer. 1.24. What is the ratio of the Secondary income (in US$) in Lesotho in 2007 to that in 2009?
Give a very brief answer. 0.39. What is the ratio of the Secondary income (in US$) of Madagascar in 2007 to that in 2009?
Offer a very short reply. 0.63. What is the ratio of the Secondary income (in US$) of Suriname in 2007 to that in 2009?
Give a very brief answer. 1.17. What is the ratio of the Secondary income (in US$) of Lesotho in 2007 to that in 2010?
Your answer should be very brief. 0.18. What is the ratio of the Secondary income (in US$) of Madagascar in 2007 to that in 2010?
Your answer should be compact. 0.98. What is the ratio of the Secondary income (in US$) of Suriname in 2007 to that in 2010?
Your response must be concise. 1.13. What is the ratio of the Secondary income (in US$) of Lesotho in 2007 to that in 2011?
Your answer should be very brief. 0.07. What is the ratio of the Secondary income (in US$) in Madagascar in 2007 to that in 2011?
Provide a short and direct response. 1.74. What is the ratio of the Secondary income (in US$) in Suriname in 2007 to that in 2011?
Provide a short and direct response. 0.87. What is the ratio of the Secondary income (in US$) in Lesotho in 2007 to that in 2012?
Provide a succinct answer. 0.14. What is the ratio of the Secondary income (in US$) of Madagascar in 2007 to that in 2012?
Make the answer very short. 0.86. What is the ratio of the Secondary income (in US$) of Suriname in 2007 to that in 2012?
Give a very brief answer. 0.92. What is the ratio of the Secondary income (in US$) of Lesotho in 2008 to that in 2009?
Keep it short and to the point. 0.3. What is the ratio of the Secondary income (in US$) in Madagascar in 2008 to that in 2009?
Offer a terse response. 0.75. What is the ratio of the Secondary income (in US$) in Suriname in 2008 to that in 2009?
Offer a very short reply. 0.95. What is the ratio of the Secondary income (in US$) in Lesotho in 2008 to that in 2010?
Give a very brief answer. 0.14. What is the ratio of the Secondary income (in US$) of Madagascar in 2008 to that in 2010?
Make the answer very short. 1.16. What is the ratio of the Secondary income (in US$) in Suriname in 2008 to that in 2010?
Your answer should be compact. 0.91. What is the ratio of the Secondary income (in US$) in Lesotho in 2008 to that in 2011?
Provide a short and direct response. 0.05. What is the ratio of the Secondary income (in US$) of Madagascar in 2008 to that in 2011?
Keep it short and to the point. 2.06. What is the ratio of the Secondary income (in US$) of Suriname in 2008 to that in 2011?
Ensure brevity in your answer.  0.7. What is the ratio of the Secondary income (in US$) of Lesotho in 2008 to that in 2012?
Ensure brevity in your answer.  0.11. What is the ratio of the Secondary income (in US$) in Madagascar in 2008 to that in 2012?
Keep it short and to the point. 1.03. What is the ratio of the Secondary income (in US$) of Suriname in 2008 to that in 2012?
Your response must be concise. 0.74. What is the ratio of the Secondary income (in US$) of Lesotho in 2009 to that in 2010?
Your answer should be very brief. 0.46. What is the ratio of the Secondary income (in US$) of Madagascar in 2009 to that in 2010?
Ensure brevity in your answer.  1.55. What is the ratio of the Secondary income (in US$) in Suriname in 2009 to that in 2010?
Ensure brevity in your answer.  0.96. What is the ratio of the Secondary income (in US$) of Lesotho in 2009 to that in 2011?
Provide a short and direct response. 0.17. What is the ratio of the Secondary income (in US$) in Madagascar in 2009 to that in 2011?
Make the answer very short. 2.75. What is the ratio of the Secondary income (in US$) in Suriname in 2009 to that in 2011?
Give a very brief answer. 0.74. What is the ratio of the Secondary income (in US$) of Lesotho in 2009 to that in 2012?
Ensure brevity in your answer.  0.35. What is the ratio of the Secondary income (in US$) of Madagascar in 2009 to that in 2012?
Provide a short and direct response. 1.37. What is the ratio of the Secondary income (in US$) in Suriname in 2009 to that in 2012?
Your answer should be compact. 0.78. What is the ratio of the Secondary income (in US$) of Lesotho in 2010 to that in 2011?
Keep it short and to the point. 0.36. What is the ratio of the Secondary income (in US$) of Madagascar in 2010 to that in 2011?
Ensure brevity in your answer.  1.77. What is the ratio of the Secondary income (in US$) in Suriname in 2010 to that in 2011?
Provide a succinct answer. 0.77. What is the ratio of the Secondary income (in US$) of Lesotho in 2010 to that in 2012?
Your response must be concise. 0.76. What is the ratio of the Secondary income (in US$) of Madagascar in 2010 to that in 2012?
Your answer should be compact. 0.88. What is the ratio of the Secondary income (in US$) in Suriname in 2010 to that in 2012?
Your answer should be very brief. 0.81. What is the ratio of the Secondary income (in US$) in Lesotho in 2011 to that in 2012?
Offer a very short reply. 2.1. What is the ratio of the Secondary income (in US$) of Madagascar in 2011 to that in 2012?
Ensure brevity in your answer.  0.5. What is the ratio of the Secondary income (in US$) in Suriname in 2011 to that in 2012?
Offer a very short reply. 1.06. What is the difference between the highest and the second highest Secondary income (in US$) of Lesotho?
Your answer should be compact. 9.39e+05. What is the difference between the highest and the second highest Secondary income (in US$) in Madagascar?
Give a very brief answer. 1.70e+07. What is the difference between the highest and the second highest Secondary income (in US$) in Suriname?
Ensure brevity in your answer.  4.09e+06. What is the difference between the highest and the lowest Secondary income (in US$) of Lesotho?
Offer a terse response. 1.76e+06. What is the difference between the highest and the lowest Secondary income (in US$) in Madagascar?
Your answer should be compact. 4.32e+07. What is the difference between the highest and the lowest Secondary income (in US$) of Suriname?
Offer a terse response. 4.19e+07. 